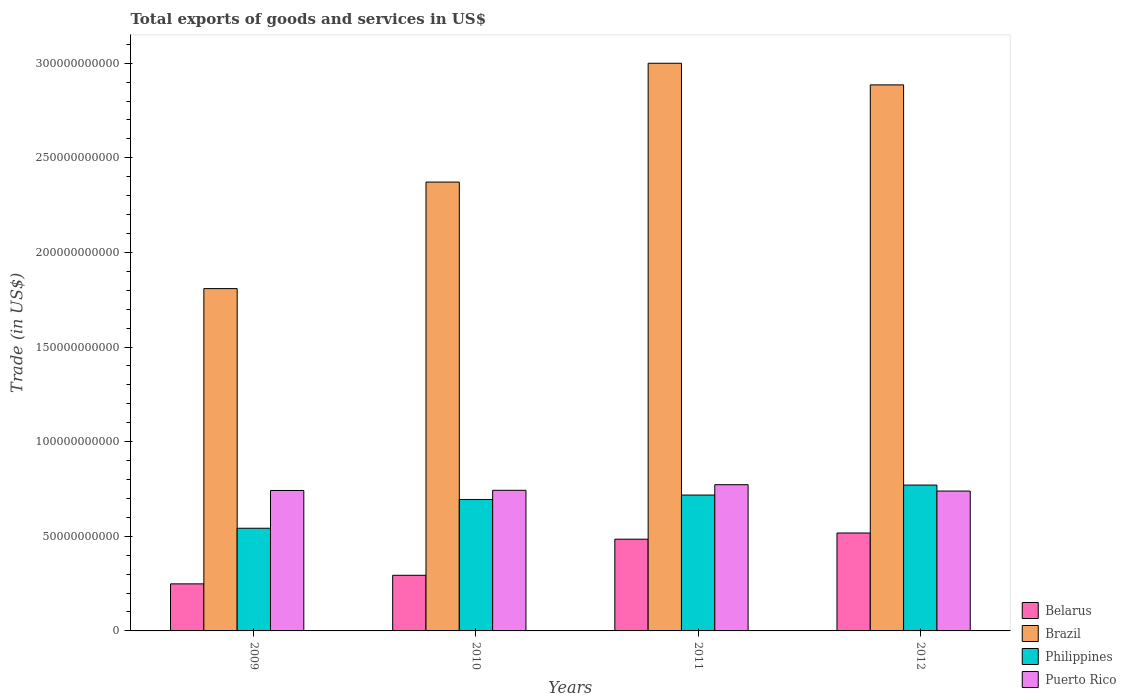How many different coloured bars are there?
Your answer should be compact. 4. How many groups of bars are there?
Offer a very short reply. 4. Are the number of bars per tick equal to the number of legend labels?
Provide a short and direct response. Yes. How many bars are there on the 2nd tick from the left?
Ensure brevity in your answer.  4. What is the total exports of goods and services in Philippines in 2009?
Give a very brief answer. 5.43e+1. Across all years, what is the maximum total exports of goods and services in Philippines?
Keep it short and to the point. 7.71e+1. Across all years, what is the minimum total exports of goods and services in Puerto Rico?
Your answer should be very brief. 7.39e+1. In which year was the total exports of goods and services in Puerto Rico maximum?
Your answer should be very brief. 2011. What is the total total exports of goods and services in Belarus in the graph?
Offer a terse response. 1.54e+11. What is the difference between the total exports of goods and services in Brazil in 2011 and that in 2012?
Offer a very short reply. 1.14e+1. What is the difference between the total exports of goods and services in Belarus in 2011 and the total exports of goods and services in Brazil in 2012?
Offer a very short reply. -2.40e+11. What is the average total exports of goods and services in Puerto Rico per year?
Offer a very short reply. 7.49e+1. In the year 2011, what is the difference between the total exports of goods and services in Belarus and total exports of goods and services in Puerto Rico?
Keep it short and to the point. -2.88e+1. What is the ratio of the total exports of goods and services in Philippines in 2009 to that in 2010?
Offer a terse response. 0.78. Is the difference between the total exports of goods and services in Belarus in 2011 and 2012 greater than the difference between the total exports of goods and services in Puerto Rico in 2011 and 2012?
Your answer should be very brief. No. What is the difference between the highest and the second highest total exports of goods and services in Belarus?
Your response must be concise. 3.28e+09. What is the difference between the highest and the lowest total exports of goods and services in Belarus?
Make the answer very short. 2.69e+1. In how many years, is the total exports of goods and services in Brazil greater than the average total exports of goods and services in Brazil taken over all years?
Offer a very short reply. 2. Is it the case that in every year, the sum of the total exports of goods and services in Philippines and total exports of goods and services in Brazil is greater than the sum of total exports of goods and services in Puerto Rico and total exports of goods and services in Belarus?
Your response must be concise. Yes. What does the 1st bar from the left in 2011 represents?
Give a very brief answer. Belarus. What does the 2nd bar from the right in 2012 represents?
Your response must be concise. Philippines. Is it the case that in every year, the sum of the total exports of goods and services in Puerto Rico and total exports of goods and services in Philippines is greater than the total exports of goods and services in Belarus?
Provide a succinct answer. Yes. How many bars are there?
Your answer should be very brief. 16. How many years are there in the graph?
Provide a short and direct response. 4. What is the difference between two consecutive major ticks on the Y-axis?
Provide a short and direct response. 5.00e+1. Are the values on the major ticks of Y-axis written in scientific E-notation?
Offer a terse response. No. Does the graph contain any zero values?
Give a very brief answer. No. Where does the legend appear in the graph?
Ensure brevity in your answer.  Bottom right. How many legend labels are there?
Your response must be concise. 4. How are the legend labels stacked?
Your response must be concise. Vertical. What is the title of the graph?
Provide a succinct answer. Total exports of goods and services in US$. Does "Niger" appear as one of the legend labels in the graph?
Your answer should be compact. No. What is the label or title of the Y-axis?
Provide a short and direct response. Trade (in US$). What is the Trade (in US$) of Belarus in 2009?
Your response must be concise. 2.49e+1. What is the Trade (in US$) in Brazil in 2009?
Your answer should be very brief. 1.81e+11. What is the Trade (in US$) of Philippines in 2009?
Your answer should be compact. 5.43e+1. What is the Trade (in US$) in Puerto Rico in 2009?
Your answer should be compact. 7.42e+1. What is the Trade (in US$) in Belarus in 2010?
Your response must be concise. 2.94e+1. What is the Trade (in US$) in Brazil in 2010?
Ensure brevity in your answer.  2.37e+11. What is the Trade (in US$) in Philippines in 2010?
Give a very brief answer. 6.95e+1. What is the Trade (in US$) in Puerto Rico in 2010?
Offer a terse response. 7.43e+1. What is the Trade (in US$) in Belarus in 2011?
Your answer should be very brief. 4.85e+1. What is the Trade (in US$) of Brazil in 2011?
Provide a short and direct response. 3.00e+11. What is the Trade (in US$) of Philippines in 2011?
Your answer should be very brief. 7.18e+1. What is the Trade (in US$) in Puerto Rico in 2011?
Give a very brief answer. 7.73e+1. What is the Trade (in US$) of Belarus in 2012?
Offer a terse response. 5.17e+1. What is the Trade (in US$) of Brazil in 2012?
Your response must be concise. 2.89e+11. What is the Trade (in US$) in Philippines in 2012?
Offer a very short reply. 7.71e+1. What is the Trade (in US$) of Puerto Rico in 2012?
Provide a succinct answer. 7.39e+1. Across all years, what is the maximum Trade (in US$) in Belarus?
Provide a succinct answer. 5.17e+1. Across all years, what is the maximum Trade (in US$) of Brazil?
Your answer should be compact. 3.00e+11. Across all years, what is the maximum Trade (in US$) in Philippines?
Make the answer very short. 7.71e+1. Across all years, what is the maximum Trade (in US$) of Puerto Rico?
Give a very brief answer. 7.73e+1. Across all years, what is the minimum Trade (in US$) of Belarus?
Keep it short and to the point. 2.49e+1. Across all years, what is the minimum Trade (in US$) of Brazil?
Ensure brevity in your answer.  1.81e+11. Across all years, what is the minimum Trade (in US$) in Philippines?
Ensure brevity in your answer.  5.43e+1. Across all years, what is the minimum Trade (in US$) in Puerto Rico?
Provide a short and direct response. 7.39e+1. What is the total Trade (in US$) of Belarus in the graph?
Keep it short and to the point. 1.54e+11. What is the total Trade (in US$) in Brazil in the graph?
Your answer should be compact. 1.01e+12. What is the total Trade (in US$) of Philippines in the graph?
Your response must be concise. 2.73e+11. What is the total Trade (in US$) in Puerto Rico in the graph?
Your answer should be very brief. 3.00e+11. What is the difference between the Trade (in US$) in Belarus in 2009 and that in 2010?
Make the answer very short. -4.54e+09. What is the difference between the Trade (in US$) in Brazil in 2009 and that in 2010?
Provide a short and direct response. -5.63e+1. What is the difference between the Trade (in US$) in Philippines in 2009 and that in 2010?
Offer a very short reply. -1.52e+1. What is the difference between the Trade (in US$) in Puerto Rico in 2009 and that in 2010?
Provide a succinct answer. -9.71e+07. What is the difference between the Trade (in US$) of Belarus in 2009 and that in 2011?
Make the answer very short. -2.36e+1. What is the difference between the Trade (in US$) in Brazil in 2009 and that in 2011?
Provide a short and direct response. -1.19e+11. What is the difference between the Trade (in US$) in Philippines in 2009 and that in 2011?
Your response must be concise. -1.75e+1. What is the difference between the Trade (in US$) in Puerto Rico in 2009 and that in 2011?
Provide a short and direct response. -3.06e+09. What is the difference between the Trade (in US$) in Belarus in 2009 and that in 2012?
Keep it short and to the point. -2.69e+1. What is the difference between the Trade (in US$) of Brazil in 2009 and that in 2012?
Keep it short and to the point. -1.08e+11. What is the difference between the Trade (in US$) in Philippines in 2009 and that in 2012?
Provide a short and direct response. -2.28e+1. What is the difference between the Trade (in US$) in Puerto Rico in 2009 and that in 2012?
Ensure brevity in your answer.  3.04e+08. What is the difference between the Trade (in US$) in Belarus in 2010 and that in 2011?
Your response must be concise. -1.91e+1. What is the difference between the Trade (in US$) of Brazil in 2010 and that in 2011?
Keep it short and to the point. -6.28e+1. What is the difference between the Trade (in US$) in Philippines in 2010 and that in 2011?
Keep it short and to the point. -2.33e+09. What is the difference between the Trade (in US$) in Puerto Rico in 2010 and that in 2011?
Provide a short and direct response. -2.96e+09. What is the difference between the Trade (in US$) of Belarus in 2010 and that in 2012?
Provide a short and direct response. -2.23e+1. What is the difference between the Trade (in US$) in Brazil in 2010 and that in 2012?
Give a very brief answer. -5.14e+1. What is the difference between the Trade (in US$) in Philippines in 2010 and that in 2012?
Offer a terse response. -7.61e+09. What is the difference between the Trade (in US$) in Puerto Rico in 2010 and that in 2012?
Give a very brief answer. 4.01e+08. What is the difference between the Trade (in US$) in Belarus in 2011 and that in 2012?
Keep it short and to the point. -3.28e+09. What is the difference between the Trade (in US$) of Brazil in 2011 and that in 2012?
Offer a very short reply. 1.14e+1. What is the difference between the Trade (in US$) in Philippines in 2011 and that in 2012?
Your answer should be compact. -5.28e+09. What is the difference between the Trade (in US$) in Puerto Rico in 2011 and that in 2012?
Your answer should be compact. 3.36e+09. What is the difference between the Trade (in US$) in Belarus in 2009 and the Trade (in US$) in Brazil in 2010?
Your answer should be very brief. -2.12e+11. What is the difference between the Trade (in US$) of Belarus in 2009 and the Trade (in US$) of Philippines in 2010?
Your response must be concise. -4.46e+1. What is the difference between the Trade (in US$) in Belarus in 2009 and the Trade (in US$) in Puerto Rico in 2010?
Give a very brief answer. -4.94e+1. What is the difference between the Trade (in US$) of Brazil in 2009 and the Trade (in US$) of Philippines in 2010?
Give a very brief answer. 1.11e+11. What is the difference between the Trade (in US$) of Brazil in 2009 and the Trade (in US$) of Puerto Rico in 2010?
Give a very brief answer. 1.07e+11. What is the difference between the Trade (in US$) in Philippines in 2009 and the Trade (in US$) in Puerto Rico in 2010?
Keep it short and to the point. -2.01e+1. What is the difference between the Trade (in US$) of Belarus in 2009 and the Trade (in US$) of Brazil in 2011?
Offer a terse response. -2.75e+11. What is the difference between the Trade (in US$) in Belarus in 2009 and the Trade (in US$) in Philippines in 2011?
Provide a succinct answer. -4.69e+1. What is the difference between the Trade (in US$) in Belarus in 2009 and the Trade (in US$) in Puerto Rico in 2011?
Ensure brevity in your answer.  -5.24e+1. What is the difference between the Trade (in US$) in Brazil in 2009 and the Trade (in US$) in Philippines in 2011?
Provide a short and direct response. 1.09e+11. What is the difference between the Trade (in US$) in Brazil in 2009 and the Trade (in US$) in Puerto Rico in 2011?
Make the answer very short. 1.04e+11. What is the difference between the Trade (in US$) of Philippines in 2009 and the Trade (in US$) of Puerto Rico in 2011?
Ensure brevity in your answer.  -2.30e+1. What is the difference between the Trade (in US$) in Belarus in 2009 and the Trade (in US$) in Brazil in 2012?
Make the answer very short. -2.64e+11. What is the difference between the Trade (in US$) of Belarus in 2009 and the Trade (in US$) of Philippines in 2012?
Provide a succinct answer. -5.22e+1. What is the difference between the Trade (in US$) in Belarus in 2009 and the Trade (in US$) in Puerto Rico in 2012?
Your answer should be very brief. -4.90e+1. What is the difference between the Trade (in US$) in Brazil in 2009 and the Trade (in US$) in Philippines in 2012?
Your response must be concise. 1.04e+11. What is the difference between the Trade (in US$) of Brazil in 2009 and the Trade (in US$) of Puerto Rico in 2012?
Offer a very short reply. 1.07e+11. What is the difference between the Trade (in US$) in Philippines in 2009 and the Trade (in US$) in Puerto Rico in 2012?
Make the answer very short. -1.97e+1. What is the difference between the Trade (in US$) in Belarus in 2010 and the Trade (in US$) in Brazil in 2011?
Your response must be concise. -2.71e+11. What is the difference between the Trade (in US$) in Belarus in 2010 and the Trade (in US$) in Philippines in 2011?
Ensure brevity in your answer.  -4.24e+1. What is the difference between the Trade (in US$) of Belarus in 2010 and the Trade (in US$) of Puerto Rico in 2011?
Offer a terse response. -4.79e+1. What is the difference between the Trade (in US$) of Brazil in 2010 and the Trade (in US$) of Philippines in 2011?
Provide a short and direct response. 1.65e+11. What is the difference between the Trade (in US$) of Brazil in 2010 and the Trade (in US$) of Puerto Rico in 2011?
Ensure brevity in your answer.  1.60e+11. What is the difference between the Trade (in US$) of Philippines in 2010 and the Trade (in US$) of Puerto Rico in 2011?
Keep it short and to the point. -7.81e+09. What is the difference between the Trade (in US$) in Belarus in 2010 and the Trade (in US$) in Brazil in 2012?
Offer a very short reply. -2.59e+11. What is the difference between the Trade (in US$) in Belarus in 2010 and the Trade (in US$) in Philippines in 2012?
Your answer should be very brief. -4.77e+1. What is the difference between the Trade (in US$) in Belarus in 2010 and the Trade (in US$) in Puerto Rico in 2012?
Your answer should be compact. -4.45e+1. What is the difference between the Trade (in US$) of Brazil in 2010 and the Trade (in US$) of Philippines in 2012?
Offer a very short reply. 1.60e+11. What is the difference between the Trade (in US$) of Brazil in 2010 and the Trade (in US$) of Puerto Rico in 2012?
Provide a short and direct response. 1.63e+11. What is the difference between the Trade (in US$) in Philippines in 2010 and the Trade (in US$) in Puerto Rico in 2012?
Give a very brief answer. -4.44e+09. What is the difference between the Trade (in US$) in Belarus in 2011 and the Trade (in US$) in Brazil in 2012?
Make the answer very short. -2.40e+11. What is the difference between the Trade (in US$) of Belarus in 2011 and the Trade (in US$) of Philippines in 2012?
Offer a very short reply. -2.86e+1. What is the difference between the Trade (in US$) of Belarus in 2011 and the Trade (in US$) of Puerto Rico in 2012?
Your response must be concise. -2.54e+1. What is the difference between the Trade (in US$) of Brazil in 2011 and the Trade (in US$) of Philippines in 2012?
Offer a very short reply. 2.23e+11. What is the difference between the Trade (in US$) in Brazil in 2011 and the Trade (in US$) in Puerto Rico in 2012?
Provide a succinct answer. 2.26e+11. What is the difference between the Trade (in US$) in Philippines in 2011 and the Trade (in US$) in Puerto Rico in 2012?
Give a very brief answer. -2.11e+09. What is the average Trade (in US$) of Belarus per year?
Provide a succinct answer. 3.86e+1. What is the average Trade (in US$) in Brazil per year?
Offer a terse response. 2.52e+11. What is the average Trade (in US$) of Philippines per year?
Provide a short and direct response. 6.81e+1. What is the average Trade (in US$) of Puerto Rico per year?
Keep it short and to the point. 7.49e+1. In the year 2009, what is the difference between the Trade (in US$) in Belarus and Trade (in US$) in Brazil?
Make the answer very short. -1.56e+11. In the year 2009, what is the difference between the Trade (in US$) of Belarus and Trade (in US$) of Philippines?
Make the answer very short. -2.94e+1. In the year 2009, what is the difference between the Trade (in US$) of Belarus and Trade (in US$) of Puerto Rico?
Offer a terse response. -4.93e+1. In the year 2009, what is the difference between the Trade (in US$) of Brazil and Trade (in US$) of Philippines?
Provide a succinct answer. 1.27e+11. In the year 2009, what is the difference between the Trade (in US$) of Brazil and Trade (in US$) of Puerto Rico?
Provide a succinct answer. 1.07e+11. In the year 2009, what is the difference between the Trade (in US$) in Philippines and Trade (in US$) in Puerto Rico?
Your answer should be very brief. -2.00e+1. In the year 2010, what is the difference between the Trade (in US$) in Belarus and Trade (in US$) in Brazil?
Provide a short and direct response. -2.08e+11. In the year 2010, what is the difference between the Trade (in US$) in Belarus and Trade (in US$) in Philippines?
Your answer should be compact. -4.01e+1. In the year 2010, what is the difference between the Trade (in US$) in Belarus and Trade (in US$) in Puerto Rico?
Offer a very short reply. -4.49e+1. In the year 2010, what is the difference between the Trade (in US$) of Brazil and Trade (in US$) of Philippines?
Your answer should be compact. 1.68e+11. In the year 2010, what is the difference between the Trade (in US$) in Brazil and Trade (in US$) in Puerto Rico?
Your answer should be compact. 1.63e+11. In the year 2010, what is the difference between the Trade (in US$) in Philippines and Trade (in US$) in Puerto Rico?
Keep it short and to the point. -4.85e+09. In the year 2011, what is the difference between the Trade (in US$) of Belarus and Trade (in US$) of Brazil?
Ensure brevity in your answer.  -2.52e+11. In the year 2011, what is the difference between the Trade (in US$) of Belarus and Trade (in US$) of Philippines?
Provide a short and direct response. -2.33e+1. In the year 2011, what is the difference between the Trade (in US$) in Belarus and Trade (in US$) in Puerto Rico?
Provide a short and direct response. -2.88e+1. In the year 2011, what is the difference between the Trade (in US$) in Brazil and Trade (in US$) in Philippines?
Ensure brevity in your answer.  2.28e+11. In the year 2011, what is the difference between the Trade (in US$) in Brazil and Trade (in US$) in Puerto Rico?
Offer a terse response. 2.23e+11. In the year 2011, what is the difference between the Trade (in US$) of Philippines and Trade (in US$) of Puerto Rico?
Offer a very short reply. -5.48e+09. In the year 2012, what is the difference between the Trade (in US$) of Belarus and Trade (in US$) of Brazil?
Offer a terse response. -2.37e+11. In the year 2012, what is the difference between the Trade (in US$) in Belarus and Trade (in US$) in Philippines?
Give a very brief answer. -2.53e+1. In the year 2012, what is the difference between the Trade (in US$) of Belarus and Trade (in US$) of Puerto Rico?
Ensure brevity in your answer.  -2.22e+1. In the year 2012, what is the difference between the Trade (in US$) in Brazil and Trade (in US$) in Philippines?
Your answer should be very brief. 2.11e+11. In the year 2012, what is the difference between the Trade (in US$) in Brazil and Trade (in US$) in Puerto Rico?
Make the answer very short. 2.15e+11. In the year 2012, what is the difference between the Trade (in US$) of Philippines and Trade (in US$) of Puerto Rico?
Give a very brief answer. 3.17e+09. What is the ratio of the Trade (in US$) in Belarus in 2009 to that in 2010?
Ensure brevity in your answer.  0.85. What is the ratio of the Trade (in US$) of Brazil in 2009 to that in 2010?
Provide a succinct answer. 0.76. What is the ratio of the Trade (in US$) in Philippines in 2009 to that in 2010?
Your response must be concise. 0.78. What is the ratio of the Trade (in US$) of Puerto Rico in 2009 to that in 2010?
Offer a terse response. 1. What is the ratio of the Trade (in US$) of Belarus in 2009 to that in 2011?
Your response must be concise. 0.51. What is the ratio of the Trade (in US$) in Brazil in 2009 to that in 2011?
Make the answer very short. 0.6. What is the ratio of the Trade (in US$) of Philippines in 2009 to that in 2011?
Your answer should be very brief. 0.76. What is the ratio of the Trade (in US$) in Puerto Rico in 2009 to that in 2011?
Your answer should be compact. 0.96. What is the ratio of the Trade (in US$) in Belarus in 2009 to that in 2012?
Your answer should be compact. 0.48. What is the ratio of the Trade (in US$) of Brazil in 2009 to that in 2012?
Make the answer very short. 0.63. What is the ratio of the Trade (in US$) of Philippines in 2009 to that in 2012?
Ensure brevity in your answer.  0.7. What is the ratio of the Trade (in US$) in Puerto Rico in 2009 to that in 2012?
Your answer should be compact. 1. What is the ratio of the Trade (in US$) of Belarus in 2010 to that in 2011?
Offer a terse response. 0.61. What is the ratio of the Trade (in US$) in Brazil in 2010 to that in 2011?
Keep it short and to the point. 0.79. What is the ratio of the Trade (in US$) of Philippines in 2010 to that in 2011?
Give a very brief answer. 0.97. What is the ratio of the Trade (in US$) in Puerto Rico in 2010 to that in 2011?
Offer a terse response. 0.96. What is the ratio of the Trade (in US$) of Belarus in 2010 to that in 2012?
Provide a short and direct response. 0.57. What is the ratio of the Trade (in US$) of Brazil in 2010 to that in 2012?
Your answer should be compact. 0.82. What is the ratio of the Trade (in US$) in Philippines in 2010 to that in 2012?
Provide a succinct answer. 0.9. What is the ratio of the Trade (in US$) in Puerto Rico in 2010 to that in 2012?
Give a very brief answer. 1.01. What is the ratio of the Trade (in US$) in Belarus in 2011 to that in 2012?
Make the answer very short. 0.94. What is the ratio of the Trade (in US$) in Brazil in 2011 to that in 2012?
Make the answer very short. 1.04. What is the ratio of the Trade (in US$) of Philippines in 2011 to that in 2012?
Your answer should be very brief. 0.93. What is the ratio of the Trade (in US$) of Puerto Rico in 2011 to that in 2012?
Offer a very short reply. 1.05. What is the difference between the highest and the second highest Trade (in US$) of Belarus?
Make the answer very short. 3.28e+09. What is the difference between the highest and the second highest Trade (in US$) of Brazil?
Your answer should be compact. 1.14e+1. What is the difference between the highest and the second highest Trade (in US$) of Philippines?
Ensure brevity in your answer.  5.28e+09. What is the difference between the highest and the second highest Trade (in US$) in Puerto Rico?
Your response must be concise. 2.96e+09. What is the difference between the highest and the lowest Trade (in US$) of Belarus?
Offer a very short reply. 2.69e+1. What is the difference between the highest and the lowest Trade (in US$) in Brazil?
Your answer should be very brief. 1.19e+11. What is the difference between the highest and the lowest Trade (in US$) in Philippines?
Your response must be concise. 2.28e+1. What is the difference between the highest and the lowest Trade (in US$) of Puerto Rico?
Your answer should be compact. 3.36e+09. 